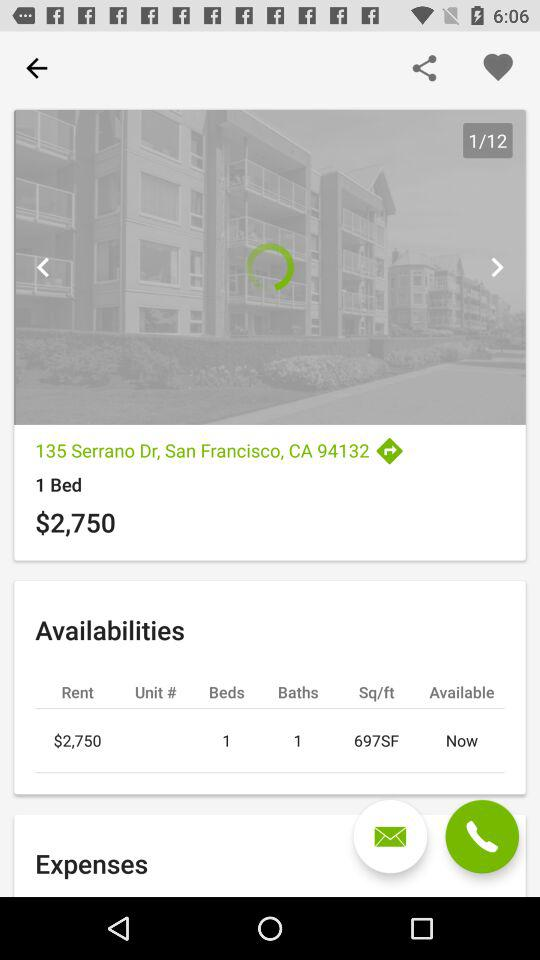What is the location? The location is 135 Serrano Dr., San Francisco, CA 94132. 